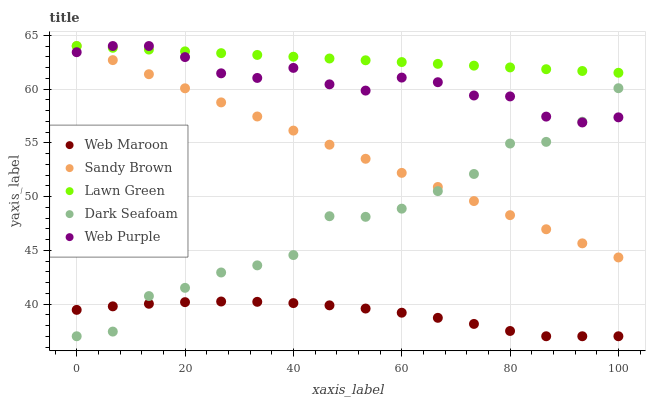Does Web Maroon have the minimum area under the curve?
Answer yes or no. Yes. Does Lawn Green have the maximum area under the curve?
Answer yes or no. Yes. Does Dark Seafoam have the minimum area under the curve?
Answer yes or no. No. Does Dark Seafoam have the maximum area under the curve?
Answer yes or no. No. Is Lawn Green the smoothest?
Answer yes or no. Yes. Is Dark Seafoam the roughest?
Answer yes or no. Yes. Is Web Maroon the smoothest?
Answer yes or no. No. Is Web Maroon the roughest?
Answer yes or no. No. Does Dark Seafoam have the lowest value?
Answer yes or no. Yes. Does Web Purple have the lowest value?
Answer yes or no. No. Does Lawn Green have the highest value?
Answer yes or no. Yes. Does Dark Seafoam have the highest value?
Answer yes or no. No. Is Web Maroon less than Sandy Brown?
Answer yes or no. Yes. Is Sandy Brown greater than Web Maroon?
Answer yes or no. Yes. Does Web Maroon intersect Dark Seafoam?
Answer yes or no. Yes. Is Web Maroon less than Dark Seafoam?
Answer yes or no. No. Is Web Maroon greater than Dark Seafoam?
Answer yes or no. No. Does Web Maroon intersect Sandy Brown?
Answer yes or no. No. 